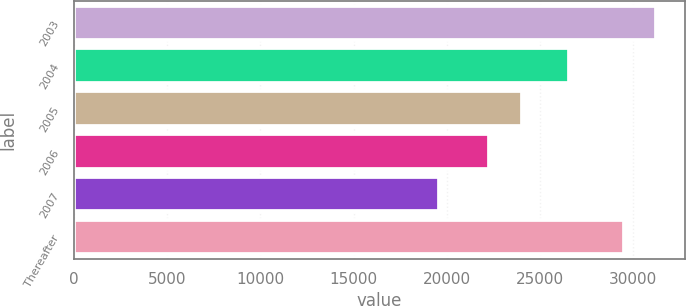<chart> <loc_0><loc_0><loc_500><loc_500><bar_chart><fcel>2003<fcel>2004<fcel>2005<fcel>2006<fcel>2007<fcel>Thereafter<nl><fcel>31211<fcel>26545<fcel>24052<fcel>22245<fcel>19597<fcel>29524<nl></chart> 